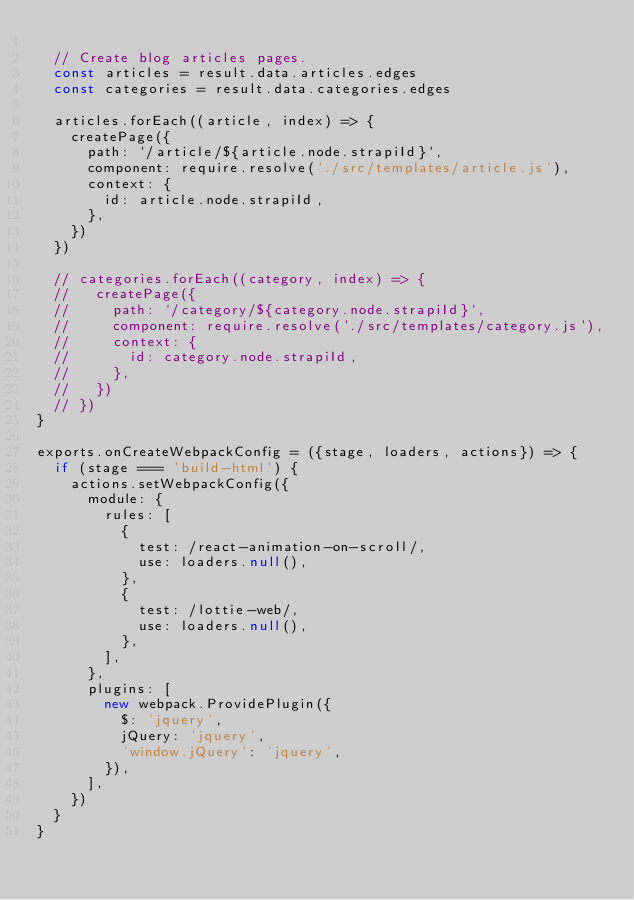<code> <loc_0><loc_0><loc_500><loc_500><_JavaScript_>
  // Create blog articles pages.
  const articles = result.data.articles.edges
  const categories = result.data.categories.edges

  articles.forEach((article, index) => {
    createPage({
      path: `/article/${article.node.strapiId}`,
      component: require.resolve('./src/templates/article.js'),
      context: {
        id: article.node.strapiId,
      },
    })
  })

  // categories.forEach((category, index) => {
  //   createPage({
  //     path: `/category/${category.node.strapiId}`,
  //     component: require.resolve('./src/templates/category.js'),
  //     context: {
  //       id: category.node.strapiId,
  //     },
  //   })
  // })
}

exports.onCreateWebpackConfig = ({stage, loaders, actions}) => {
  if (stage === 'build-html') {
    actions.setWebpackConfig({
      module: {
        rules: [
          {
            test: /react-animation-on-scroll/,
            use: loaders.null(),
          },
          {
            test: /lottie-web/,
            use: loaders.null(),
          },
        ],
      },
      plugins: [
        new webpack.ProvidePlugin({
          $: 'jquery',
          jQuery: 'jquery',
          'window.jQuery': 'jquery',
        }),
      ],
    })
  }
}
</code> 